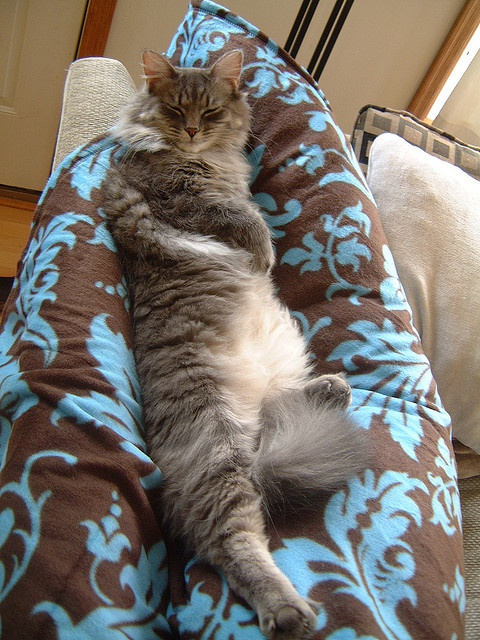Describe the objects in this image and their specific colors. I can see couch in gray, black, maroon, and darkgray tones and cat in gray, black, and darkgray tones in this image. 